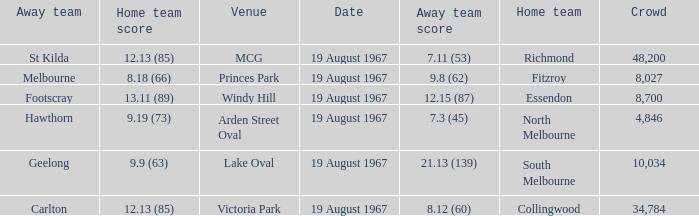If the away team scored 7.3 (45), what was the home team score? 9.19 (73). 